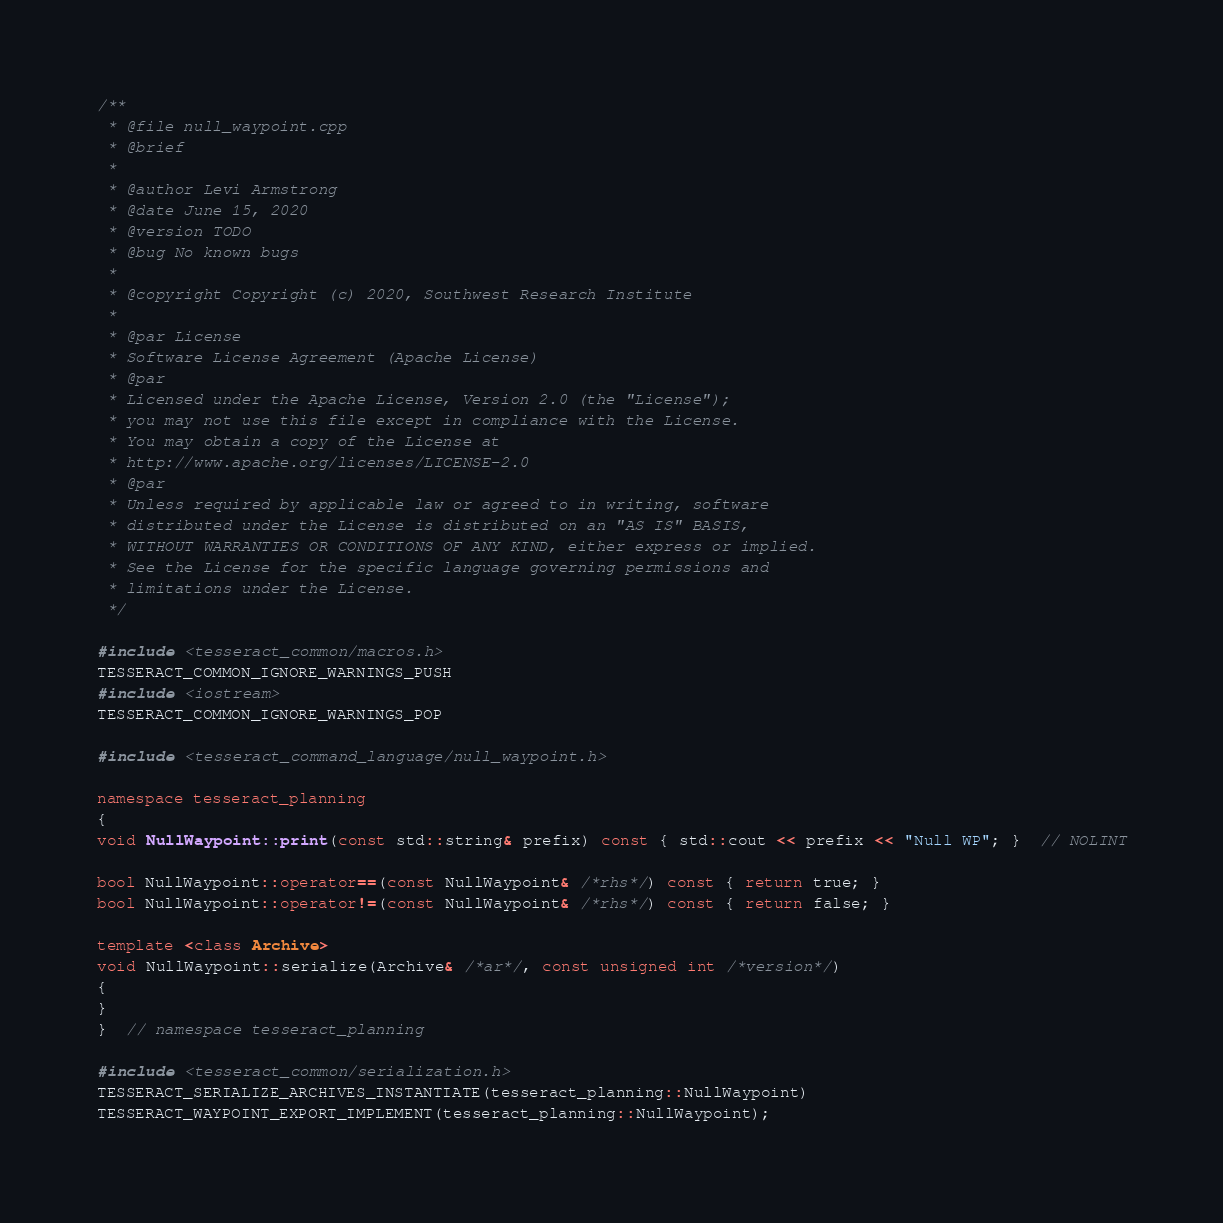<code> <loc_0><loc_0><loc_500><loc_500><_C++_>/**
 * @file null_waypoint.cpp
 * @brief
 *
 * @author Levi Armstrong
 * @date June 15, 2020
 * @version TODO
 * @bug No known bugs
 *
 * @copyright Copyright (c) 2020, Southwest Research Institute
 *
 * @par License
 * Software License Agreement (Apache License)
 * @par
 * Licensed under the Apache License, Version 2.0 (the "License");
 * you may not use this file except in compliance with the License.
 * You may obtain a copy of the License at
 * http://www.apache.org/licenses/LICENSE-2.0
 * @par
 * Unless required by applicable law or agreed to in writing, software
 * distributed under the License is distributed on an "AS IS" BASIS,
 * WITHOUT WARRANTIES OR CONDITIONS OF ANY KIND, either express or implied.
 * See the License for the specific language governing permissions and
 * limitations under the License.
 */

#include <tesseract_common/macros.h>
TESSERACT_COMMON_IGNORE_WARNINGS_PUSH
#include <iostream>
TESSERACT_COMMON_IGNORE_WARNINGS_POP

#include <tesseract_command_language/null_waypoint.h>

namespace tesseract_planning
{
void NullWaypoint::print(const std::string& prefix) const { std::cout << prefix << "Null WP"; }  // NOLINT

bool NullWaypoint::operator==(const NullWaypoint& /*rhs*/) const { return true; }
bool NullWaypoint::operator!=(const NullWaypoint& /*rhs*/) const { return false; }

template <class Archive>
void NullWaypoint::serialize(Archive& /*ar*/, const unsigned int /*version*/)
{
}
}  // namespace tesseract_planning

#include <tesseract_common/serialization.h>
TESSERACT_SERIALIZE_ARCHIVES_INSTANTIATE(tesseract_planning::NullWaypoint)
TESSERACT_WAYPOINT_EXPORT_IMPLEMENT(tesseract_planning::NullWaypoint);
</code> 